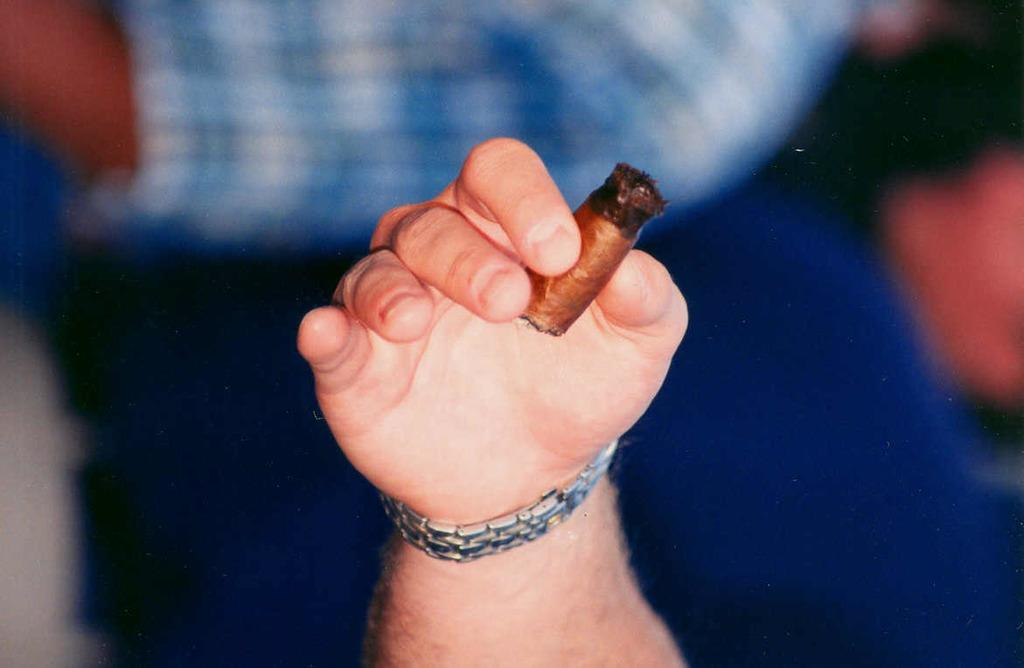What is the person's hand holding in the image? There is an object being held by the person's hand in the image. Can you describe the setting or context of the image? There are other people visible in the background of the image. What type of fruit is being held by the person's hand in the image? There is no fruit visible in the image; the person's hand is holding an object, but the nature of the object is not specified. 